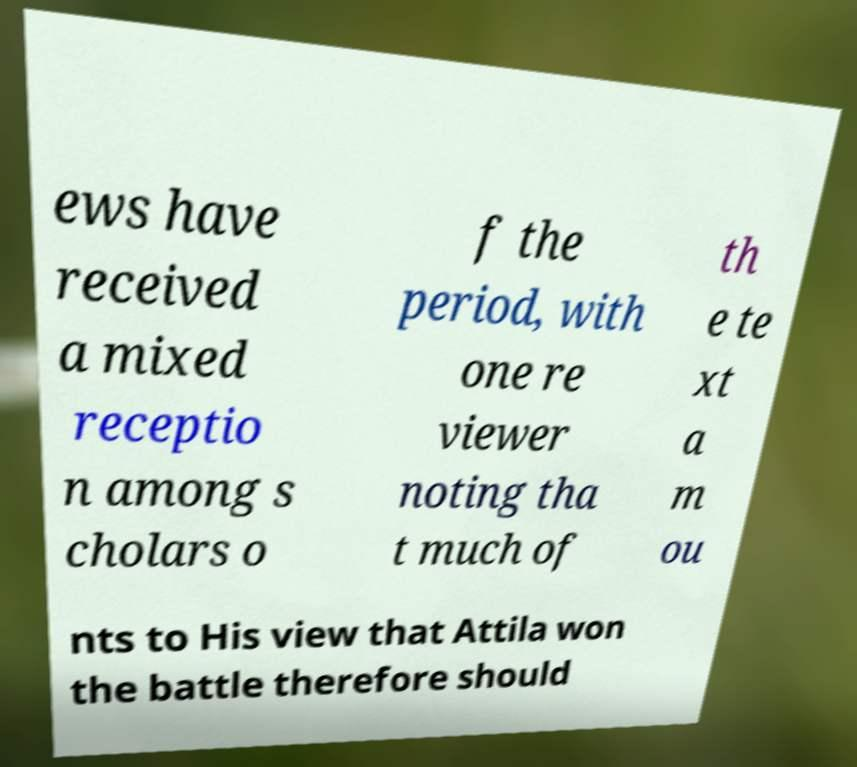Can you accurately transcribe the text from the provided image for me? ews have received a mixed receptio n among s cholars o f the period, with one re viewer noting tha t much of th e te xt a m ou nts to His view that Attila won the battle therefore should 